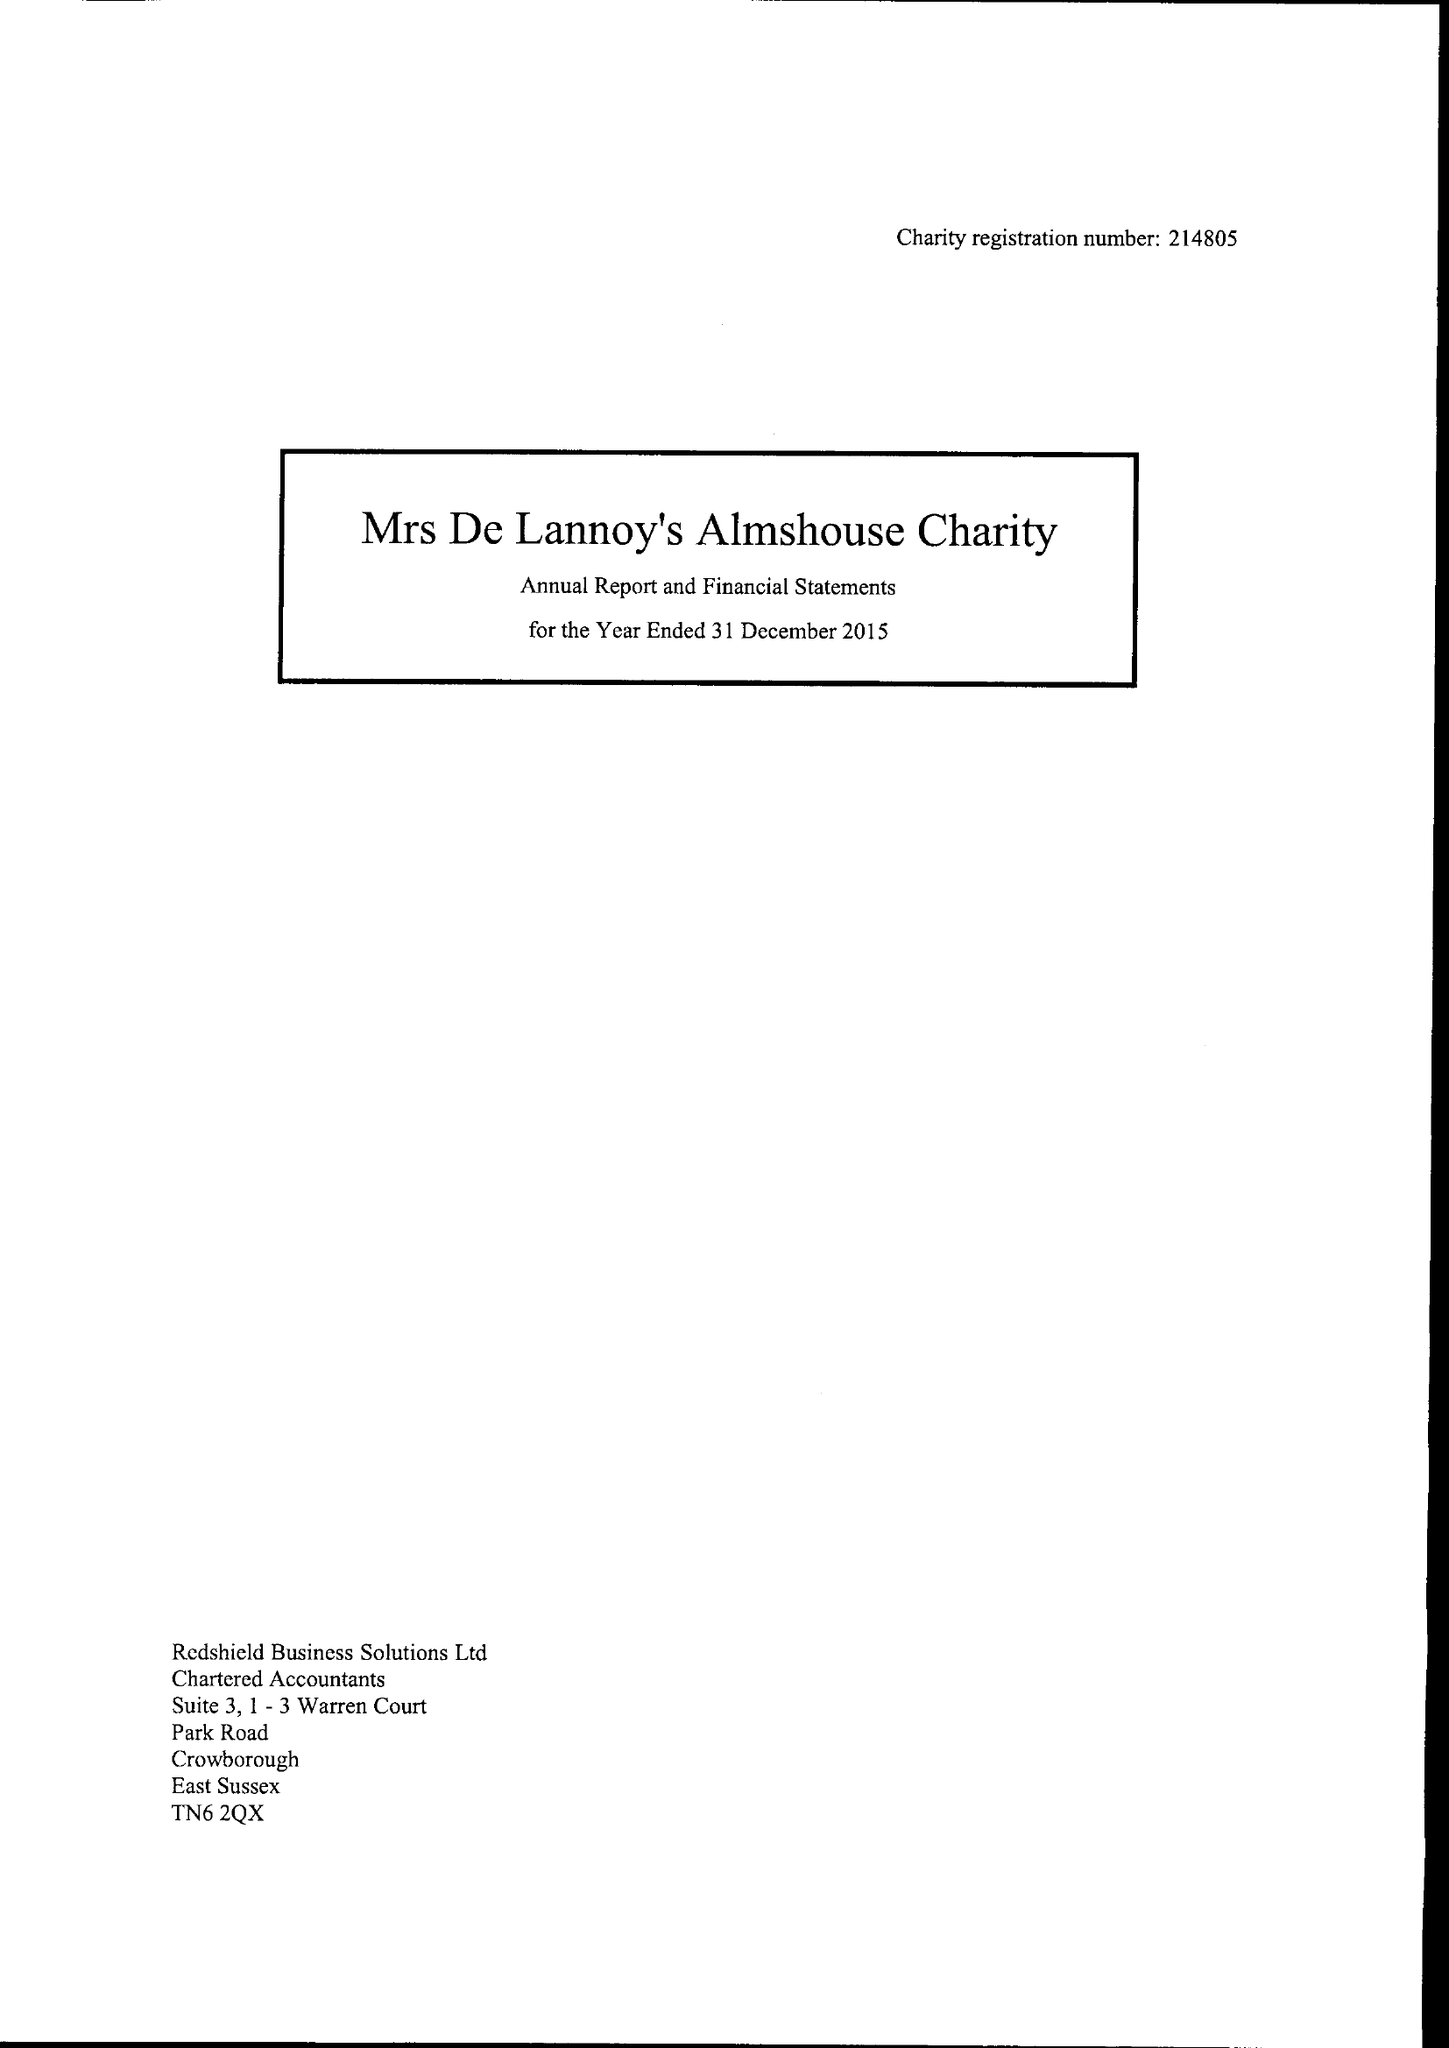What is the value for the address__street_line?
Answer the question using a single word or phrase. None 